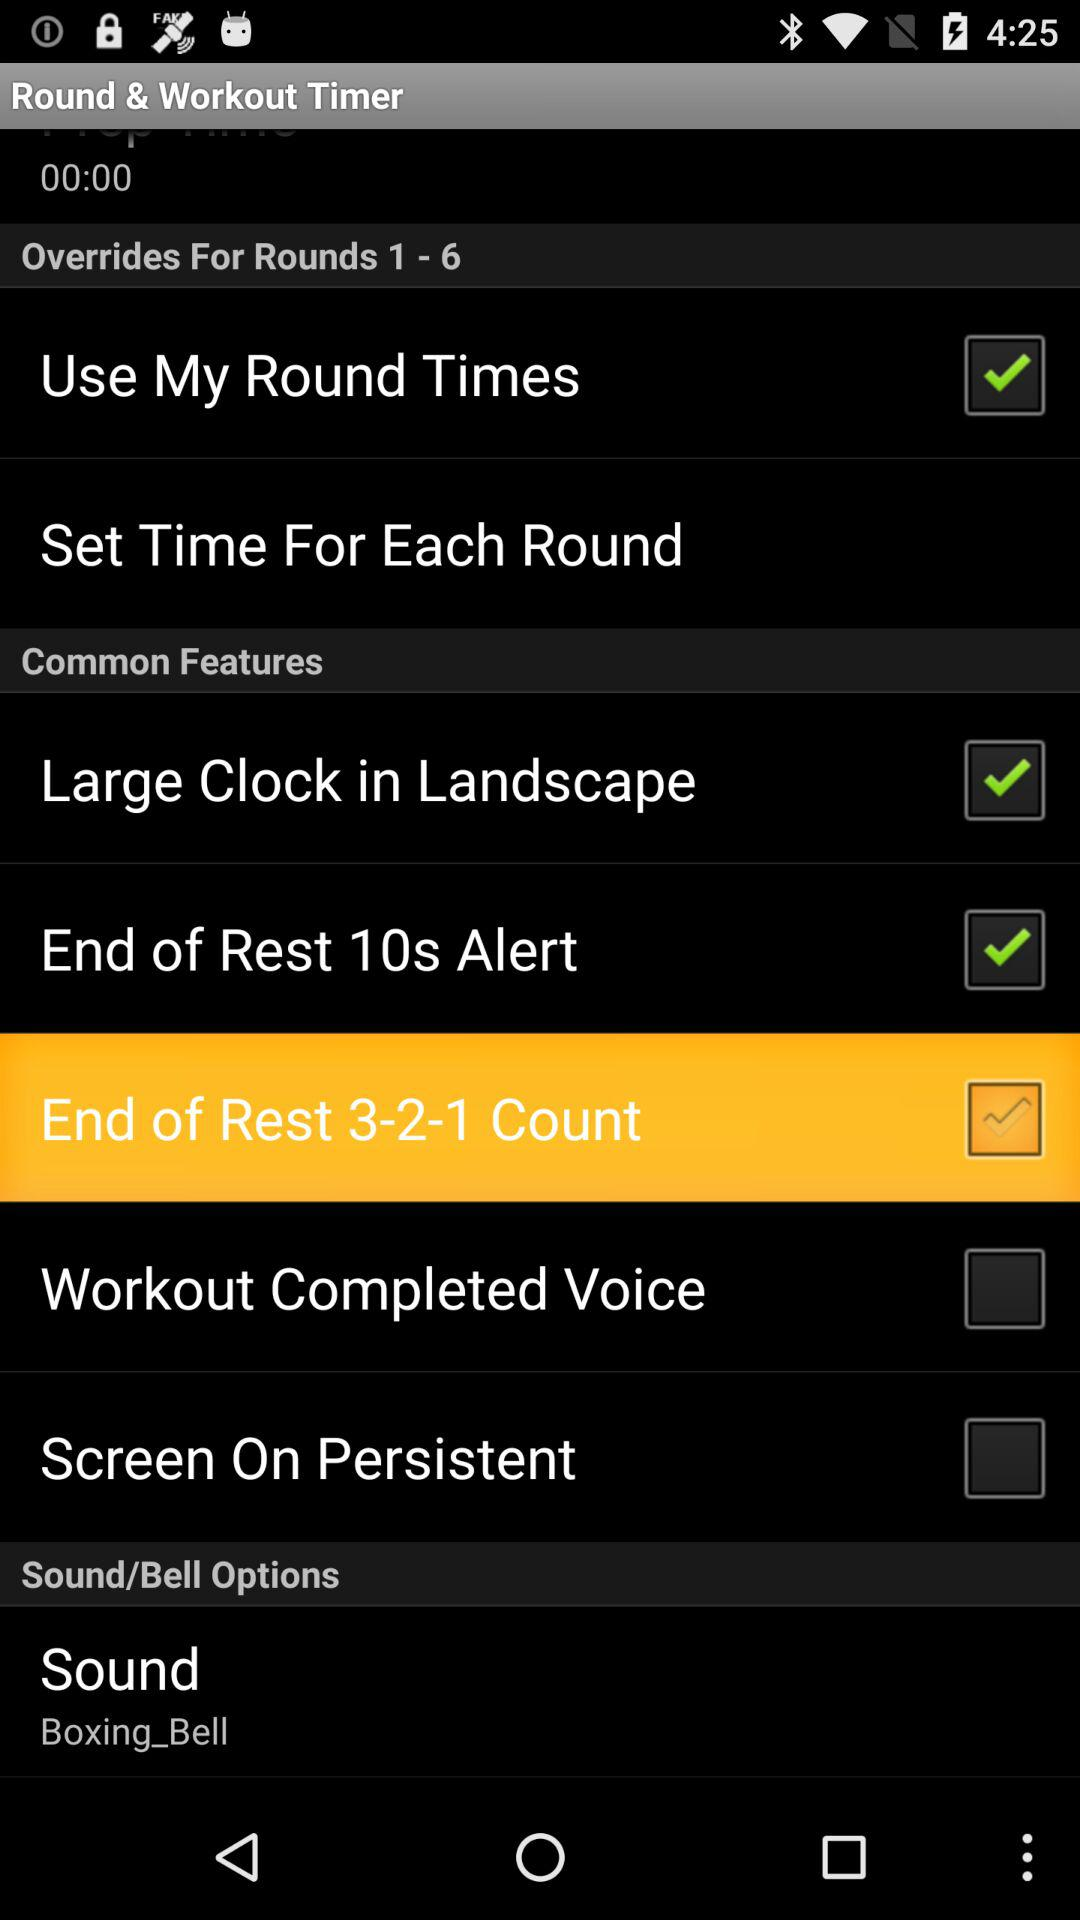What is the status of the "End of Rest 10s Alert"? The status is "on". 